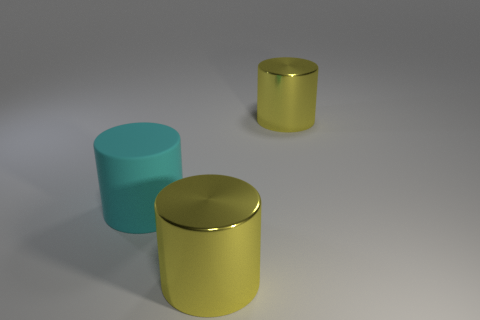Subtract all large cyan cylinders. How many cylinders are left? 2 Subtract all blue spheres. How many yellow cylinders are left? 2 Subtract 1 cylinders. How many cylinders are left? 2 Add 2 matte things. How many objects exist? 5 Subtract all green cylinders. Subtract all cyan cubes. How many cylinders are left? 3 Subtract all cyan matte objects. Subtract all yellow cylinders. How many objects are left? 0 Add 2 large cyan things. How many large cyan things are left? 3 Add 2 large cyan rubber cubes. How many large cyan rubber cubes exist? 2 Subtract 0 green cylinders. How many objects are left? 3 